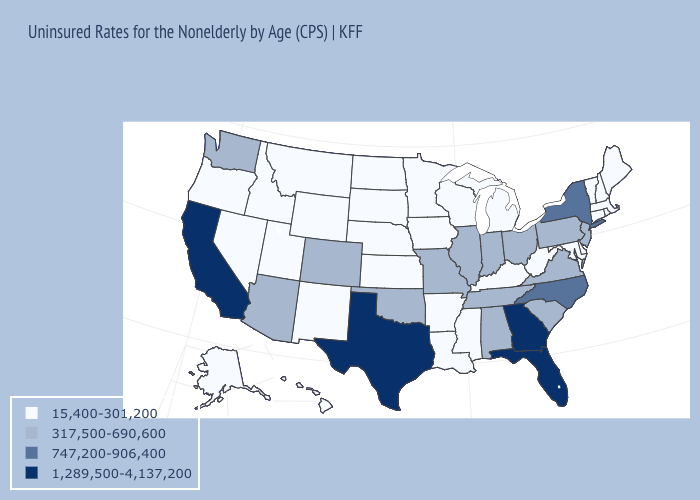Which states hav the highest value in the Northeast?
Answer briefly. New York. What is the value of Massachusetts?
Keep it brief. 15,400-301,200. Does California have the highest value in the USA?
Give a very brief answer. Yes. Does Missouri have a lower value than Florida?
Be succinct. Yes. What is the value of Missouri?
Write a very short answer. 317,500-690,600. What is the highest value in states that border Ohio?
Be succinct. 317,500-690,600. Among the states that border Connecticut , does New York have the lowest value?
Quick response, please. No. Does Indiana have a lower value than New Hampshire?
Be succinct. No. What is the value of Indiana?
Keep it brief. 317,500-690,600. Among the states that border Pennsylvania , which have the highest value?
Concise answer only. New York. What is the value of North Carolina?
Write a very short answer. 747,200-906,400. Does the map have missing data?
Be succinct. No. What is the highest value in the USA?
Answer briefly. 1,289,500-4,137,200. What is the value of Georgia?
Be succinct. 1,289,500-4,137,200. What is the highest value in states that border Louisiana?
Be succinct. 1,289,500-4,137,200. 